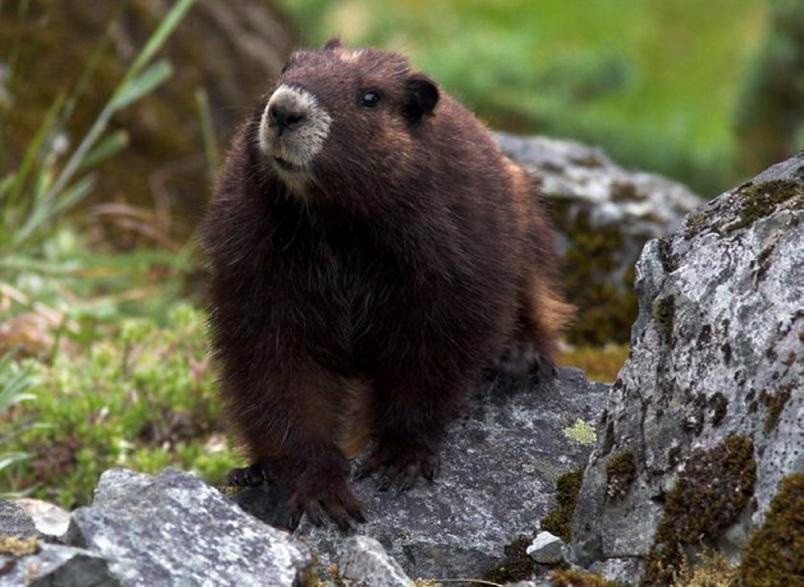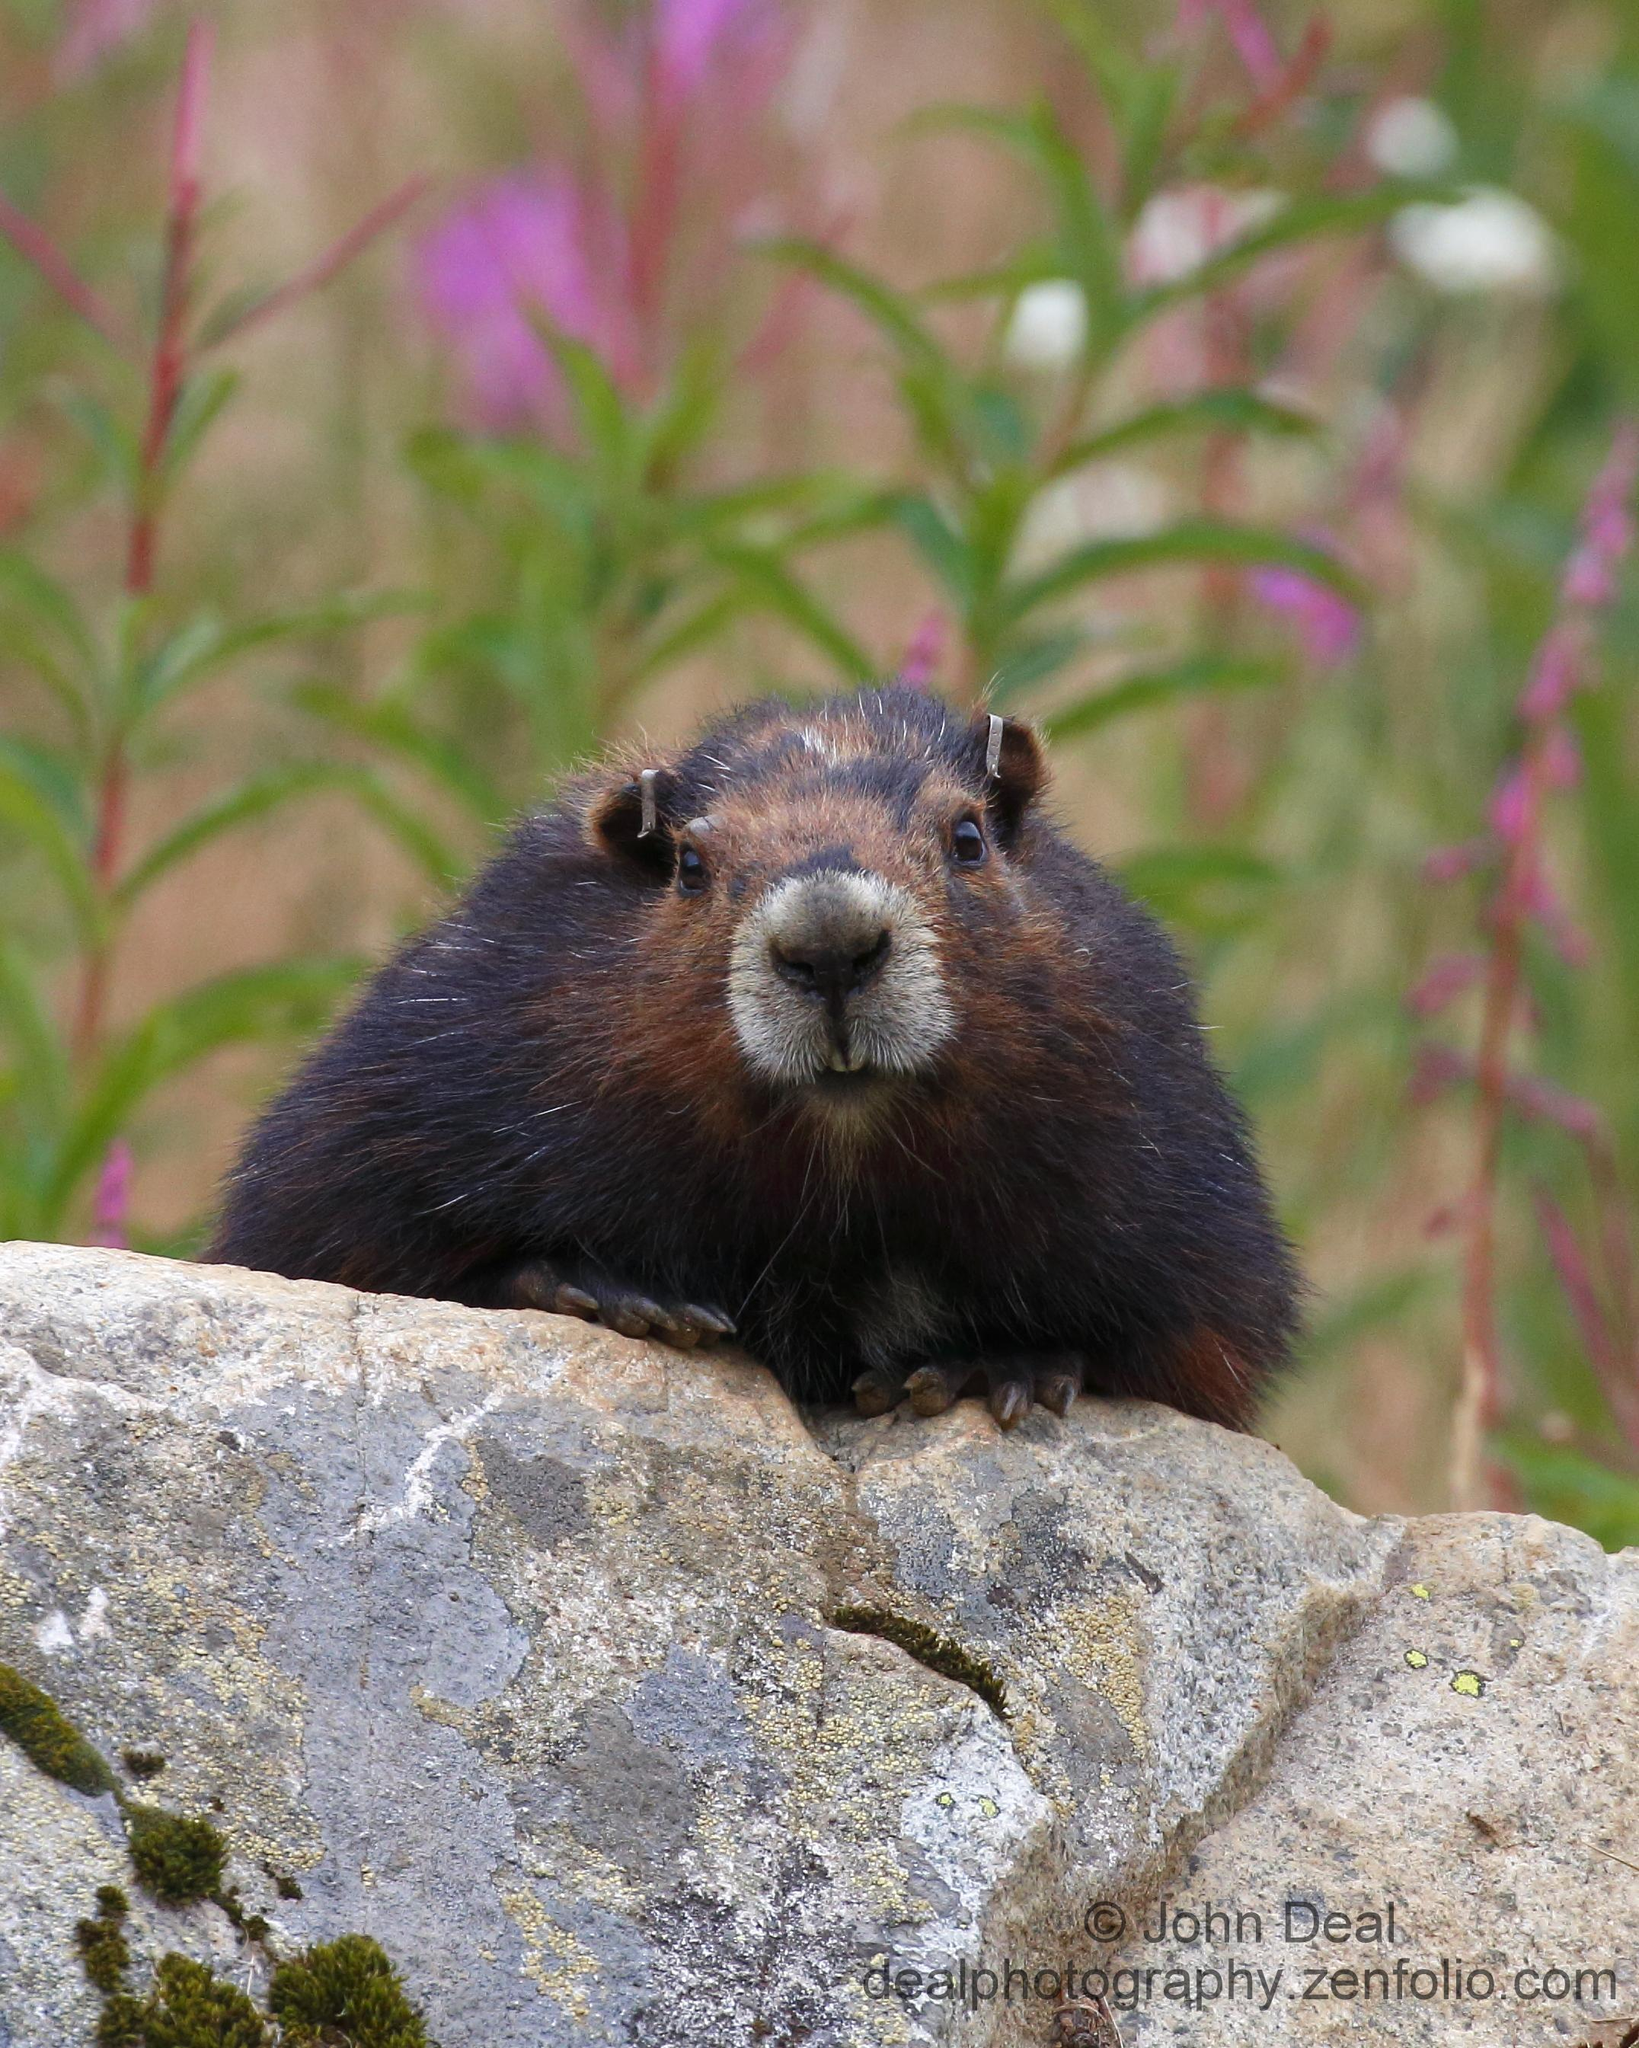The first image is the image on the left, the second image is the image on the right. Given the left and right images, does the statement "Each image contains a single marmot, and the right image features a marmot standing and facing leftward." hold true? Answer yes or no. No. The first image is the image on the left, the second image is the image on the right. Considering the images on both sides, is "There are exactly 2 marmots and one of them is standing on its hind legs." valid? Answer yes or no. No. 